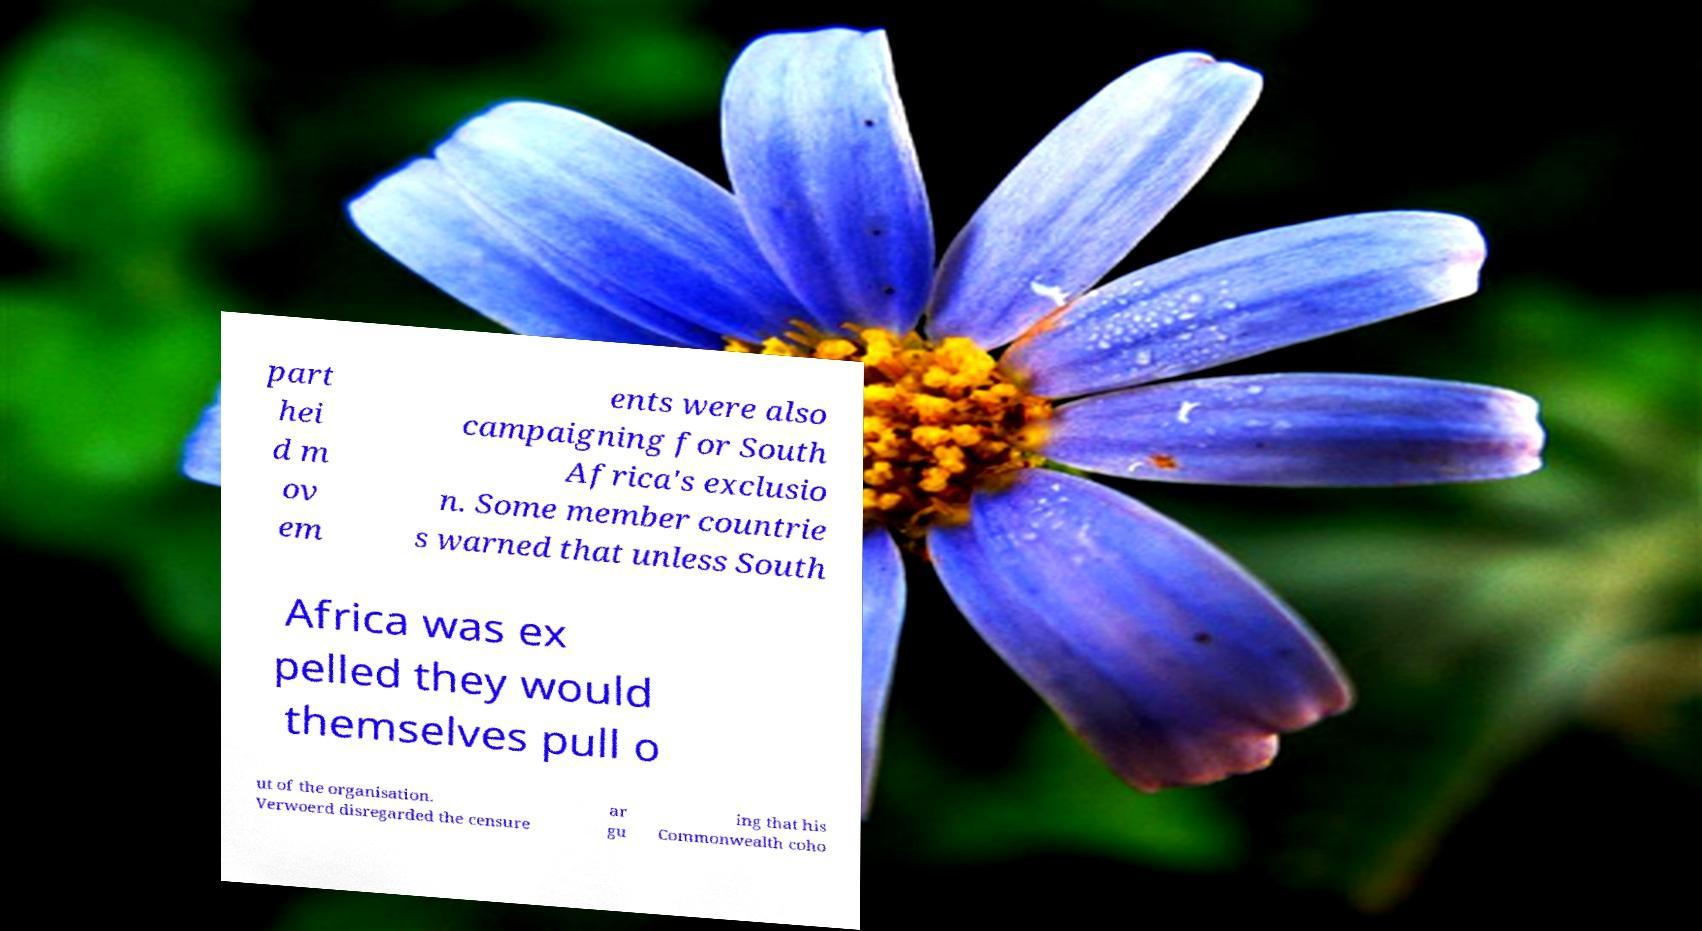Can you read and provide the text displayed in the image?This photo seems to have some interesting text. Can you extract and type it out for me? part hei d m ov em ents were also campaigning for South Africa's exclusio n. Some member countrie s warned that unless South Africa was ex pelled they would themselves pull o ut of the organisation. Verwoerd disregarded the censure ar gu ing that his Commonwealth coho 